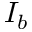<formula> <loc_0><loc_0><loc_500><loc_500>I _ { b }</formula> 